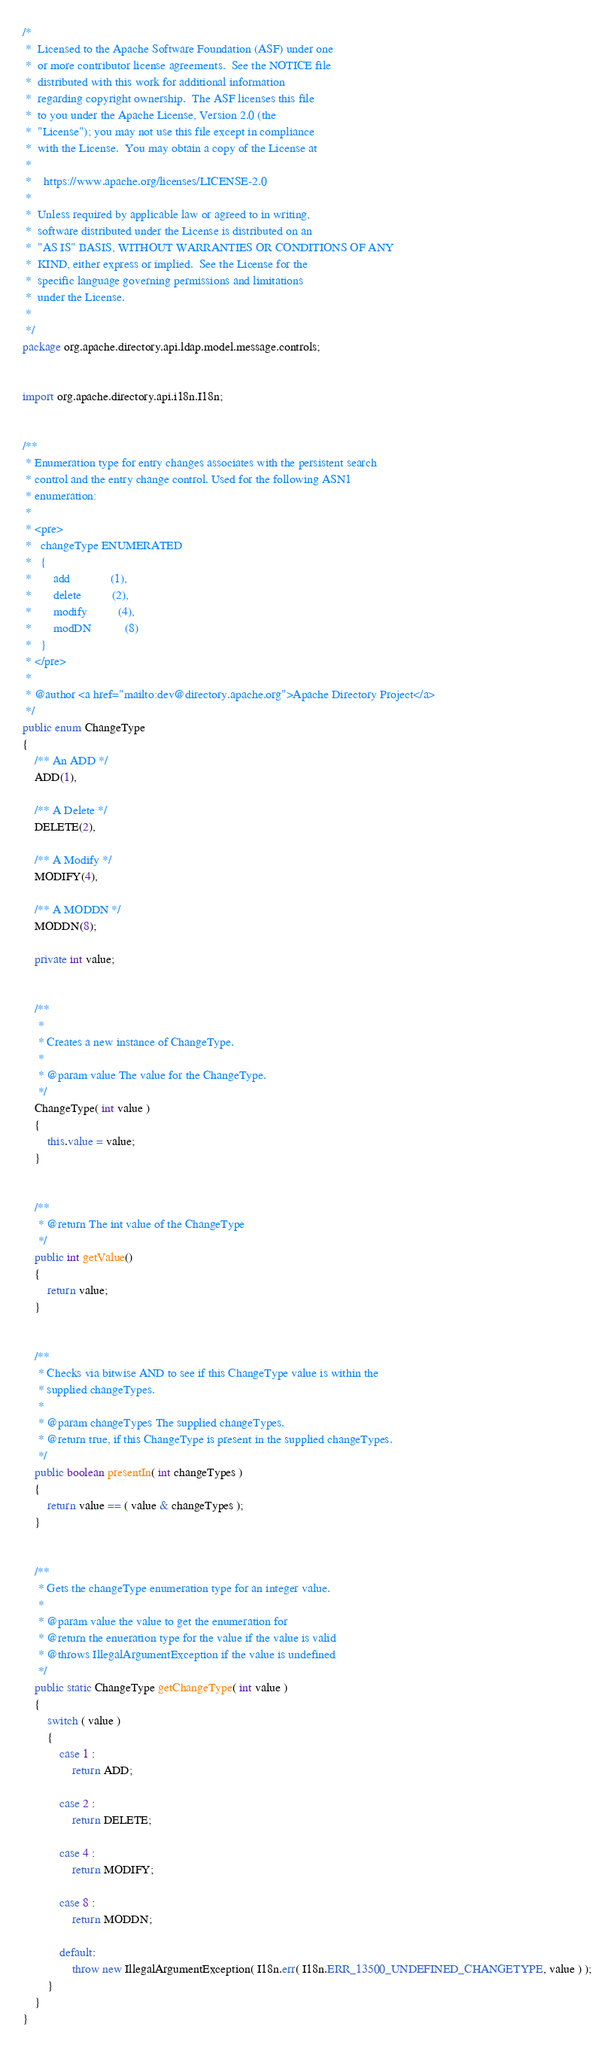<code> <loc_0><loc_0><loc_500><loc_500><_Java_>/*
 *  Licensed to the Apache Software Foundation (ASF) under one
 *  or more contributor license agreements.  See the NOTICE file
 *  distributed with this work for additional information
 *  regarding copyright ownership.  The ASF licenses this file
 *  to you under the Apache License, Version 2.0 (the
 *  "License"); you may not use this file except in compliance
 *  with the License.  You may obtain a copy of the License at
 *  
 *    https://www.apache.org/licenses/LICENSE-2.0
 *  
 *  Unless required by applicable law or agreed to in writing,
 *  software distributed under the License is distributed on an
 *  "AS IS" BASIS, WITHOUT WARRANTIES OR CONDITIONS OF ANY
 *  KIND, either express or implied.  See the License for the
 *  specific language governing permissions and limitations
 *  under the License. 
 *  
 */
package org.apache.directory.api.ldap.model.message.controls;


import org.apache.directory.api.i18n.I18n;


/**
 * Enumeration type for entry changes associates with the persistent search
 * control and the entry change control. Used for the following ASN1
 * enumeration:
 * 
 * <pre>
 *   changeType ENUMERATED 
 *   {
 *       add             (1),
 *       delete          (2),
 *       modify          (4),
 *       modDN           (8)
 *   }
 * </pre>
 * 
 * @author <a href="mailto:dev@directory.apache.org">Apache Directory Project</a>
 */
public enum ChangeType
{
    /** An ADD */
    ADD(1),

    /** A Delete */
    DELETE(2),

    /** A Modify */
    MODIFY(4),

    /** A MODDN */
    MODDN(8);

    private int value;


    /**
     * 
     * Creates a new instance of ChangeType.
     *
     * @param value The value for the ChangeType.
     */
    ChangeType( int value )
    {
        this.value = value;
    }


    /**
     * @return The int value of the ChangeType
     */
    public int getValue()
    {
        return value;
    }


    /**
     * Checks via bitwise AND to see if this ChangeType value is within the
     * supplied changeTypes.
     *
     * @param changeTypes The supplied changeTypes.
     * @return true, if this ChangeType is present in the supplied changeTypes.
     */
    public boolean presentIn( int changeTypes )
    {
        return value == ( value & changeTypes );
    }


    /**
     * Gets the changeType enumeration type for an integer value.
     * 
     * @param value the value to get the enumeration for
     * @return the enueration type for the value if the value is valid
     * @throws IllegalArgumentException if the value is undefined
     */
    public static ChangeType getChangeType( int value )
    {
        switch ( value )
        {
            case 1 :
                return ADD;
            
            case 2 :
                return DELETE;
            
            case 4 :
                return MODIFY;
            
            case 8 :
                return MODDN;
                
            default:
                throw new IllegalArgumentException( I18n.err( I18n.ERR_13500_UNDEFINED_CHANGETYPE, value ) );
        }
    }
}
</code> 